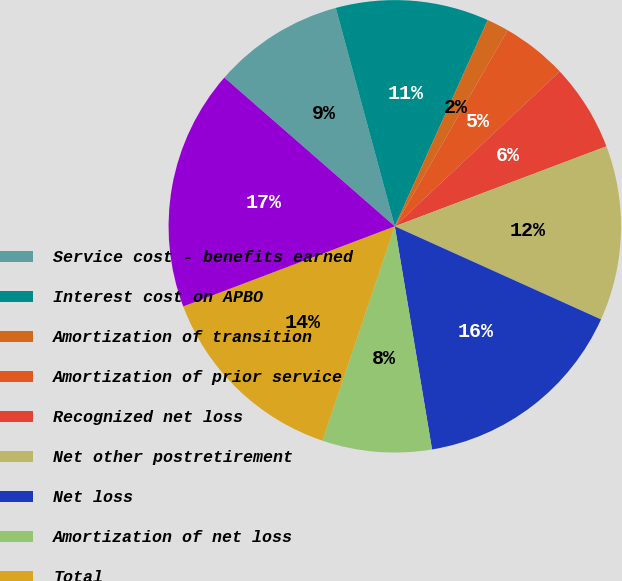Convert chart to OTSL. <chart><loc_0><loc_0><loc_500><loc_500><pie_chart><fcel>Service cost - benefits earned<fcel>Interest cost on APBO<fcel>Amortization of transition<fcel>Amortization of prior service<fcel>Recognized net loss<fcel>Net other postretirement<fcel>Net loss<fcel>Amortization of net loss<fcel>Total<fcel>Total recognized as net<nl><fcel>9.38%<fcel>10.94%<fcel>1.57%<fcel>4.69%<fcel>6.25%<fcel>12.5%<fcel>15.62%<fcel>7.81%<fcel>14.06%<fcel>17.18%<nl></chart> 